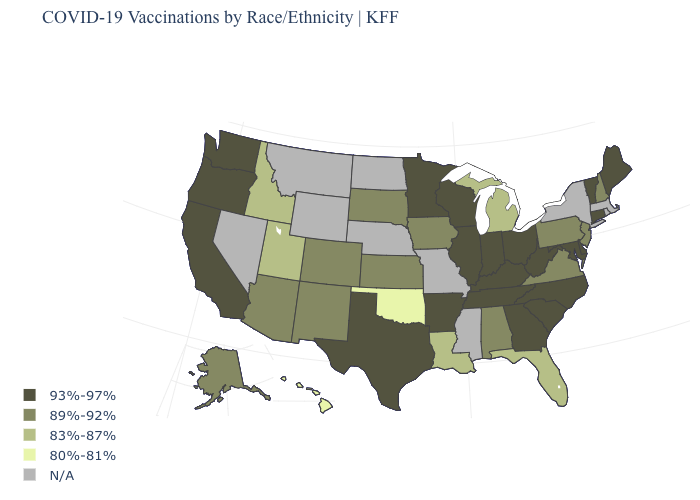Does the first symbol in the legend represent the smallest category?
Be succinct. No. Among the states that border Minnesota , which have the highest value?
Give a very brief answer. Wisconsin. Name the states that have a value in the range 80%-81%?
Short answer required. Hawaii, Oklahoma. Which states hav the highest value in the West?
Give a very brief answer. California, Oregon, Washington. Which states have the highest value in the USA?
Quick response, please. Arkansas, California, Connecticut, Delaware, Georgia, Illinois, Indiana, Kentucky, Maine, Maryland, Minnesota, North Carolina, Ohio, Oregon, South Carolina, Tennessee, Texas, Vermont, Washington, West Virginia, Wisconsin. Among the states that border Montana , which have the highest value?
Quick response, please. South Dakota. Does the map have missing data?
Short answer required. Yes. What is the lowest value in states that border Rhode Island?
Give a very brief answer. 93%-97%. What is the value of Hawaii?
Write a very short answer. 80%-81%. Name the states that have a value in the range 89%-92%?
Quick response, please. Alabama, Alaska, Arizona, Colorado, Iowa, Kansas, New Hampshire, New Jersey, New Mexico, Pennsylvania, South Dakota, Virginia. What is the highest value in the West ?
Write a very short answer. 93%-97%. Name the states that have a value in the range 93%-97%?
Give a very brief answer. Arkansas, California, Connecticut, Delaware, Georgia, Illinois, Indiana, Kentucky, Maine, Maryland, Minnesota, North Carolina, Ohio, Oregon, South Carolina, Tennessee, Texas, Vermont, Washington, West Virginia, Wisconsin. Does Kansas have the lowest value in the USA?
Keep it brief. No. Which states have the highest value in the USA?
Quick response, please. Arkansas, California, Connecticut, Delaware, Georgia, Illinois, Indiana, Kentucky, Maine, Maryland, Minnesota, North Carolina, Ohio, Oregon, South Carolina, Tennessee, Texas, Vermont, Washington, West Virginia, Wisconsin. 